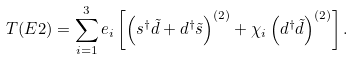<formula> <loc_0><loc_0><loc_500><loc_500>T ( E 2 ) = \sum _ { i = 1 } ^ { 3 } e _ { i } \left [ \left ( s ^ { \dag } \tilde { d } + d ^ { \dag } \tilde { s } \right ) ^ { ( 2 ) } + \chi _ { i } \left ( d ^ { \dag } \tilde { d } \right ) ^ { ( 2 ) } \right ] .</formula> 